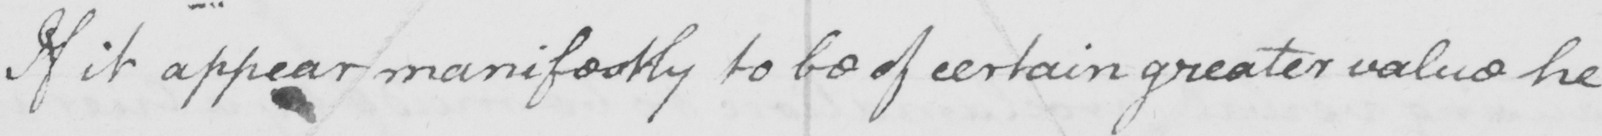What does this handwritten line say? If it appear manifestly to be of certain greater value he 